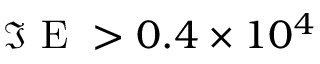<formula> <loc_0><loc_0><loc_500><loc_500>\Im E > 0 . 4 \times 1 0 ^ { 4 }</formula> 